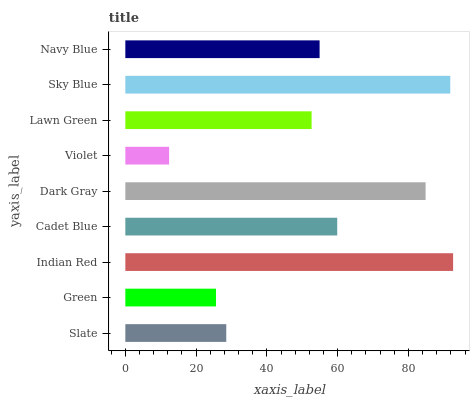Is Violet the minimum?
Answer yes or no. Yes. Is Indian Red the maximum?
Answer yes or no. Yes. Is Green the minimum?
Answer yes or no. No. Is Green the maximum?
Answer yes or no. No. Is Slate greater than Green?
Answer yes or no. Yes. Is Green less than Slate?
Answer yes or no. Yes. Is Green greater than Slate?
Answer yes or no. No. Is Slate less than Green?
Answer yes or no. No. Is Navy Blue the high median?
Answer yes or no. Yes. Is Navy Blue the low median?
Answer yes or no. Yes. Is Sky Blue the high median?
Answer yes or no. No. Is Slate the low median?
Answer yes or no. No. 